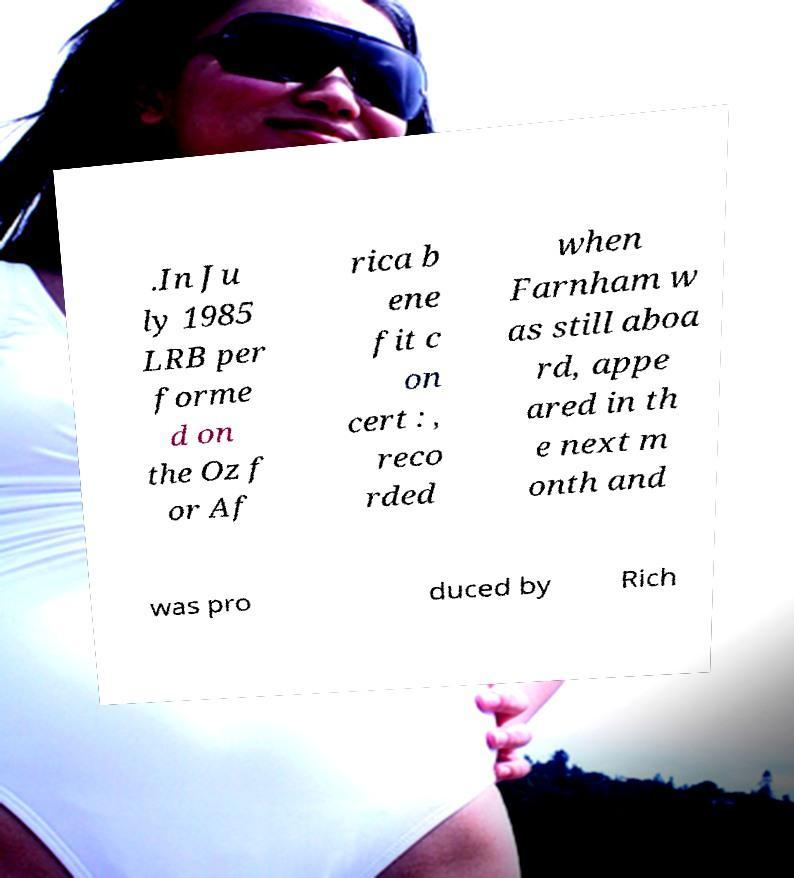Can you read and provide the text displayed in the image?This photo seems to have some interesting text. Can you extract and type it out for me? .In Ju ly 1985 LRB per forme d on the Oz f or Af rica b ene fit c on cert : , reco rded when Farnham w as still aboa rd, appe ared in th e next m onth and was pro duced by Rich 